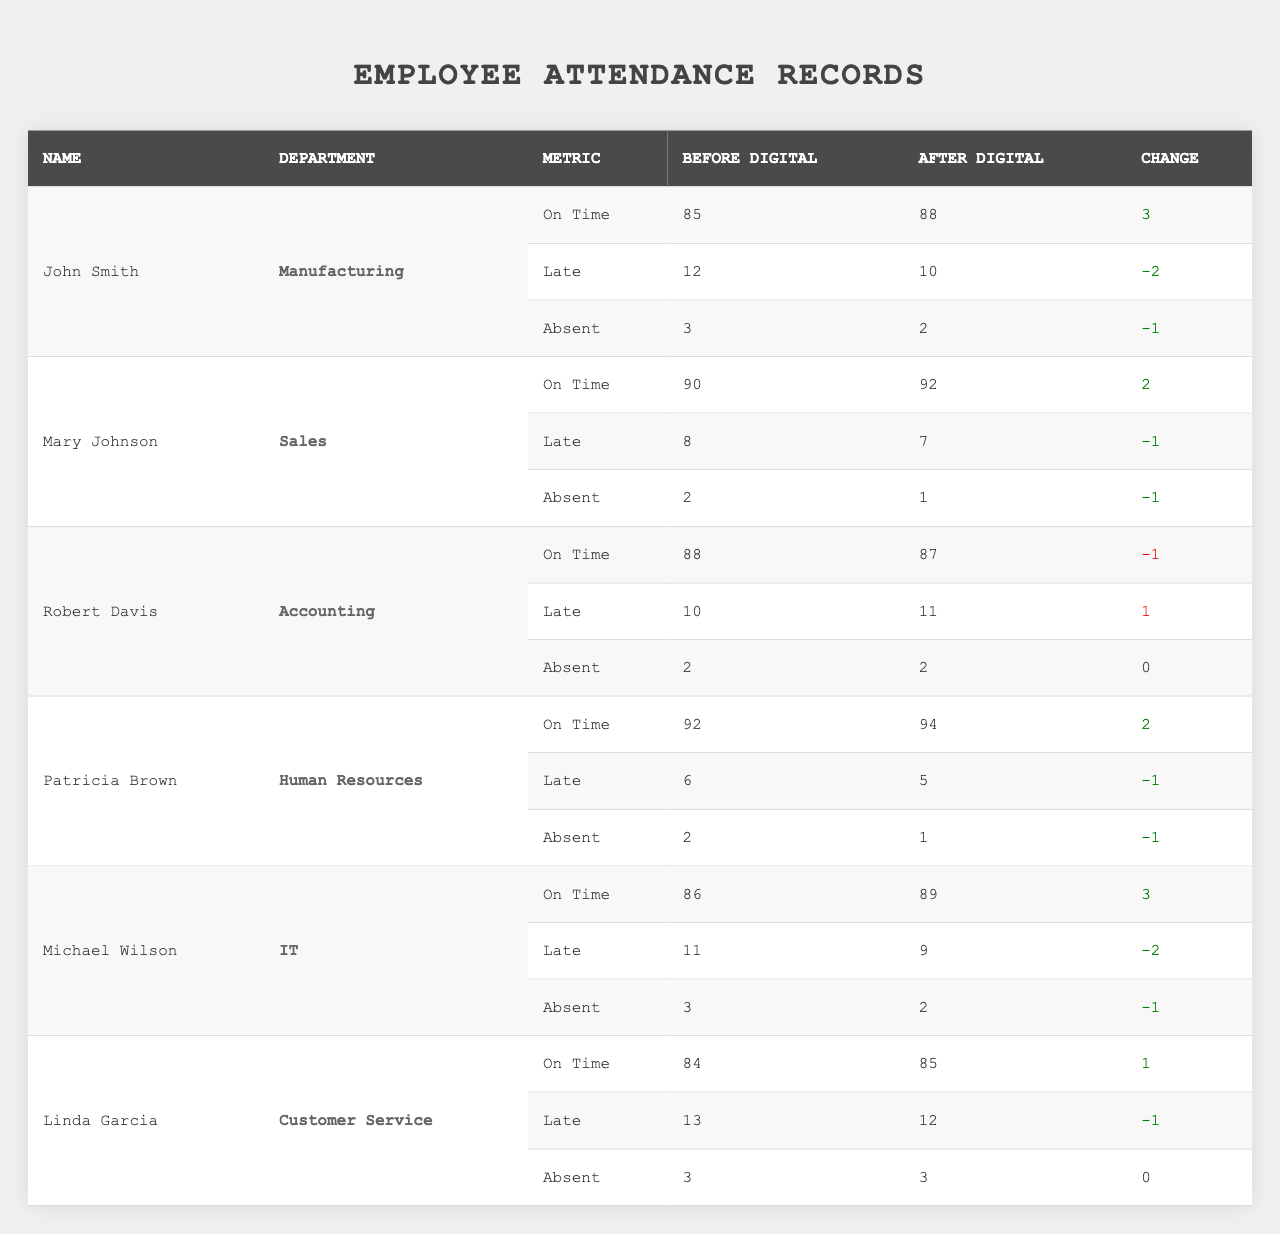What was the attendance record for John Smith before the digital check-in system? The table indicates that John Smith was on time 85 times, was late 12 times, and was absent 3 times. Therefore, the records are: On Time: 85, Late: 12, Absent: 3
Answer: 85 on time, 12 late, 3 absent Did Mary Johnson improve her on-time attendance after the digital system was implemented? By comparing the before and after values, Mary was on time 90 times before and 92 times after implementing the system. Since 92 is greater than 90, her on-time attendance improved.
Answer: Yes How many total times did Robert Davis arrive late before the digital system was in place? The table shows that Robert Davis was late 10 times before the digital system was implemented. Therefore, his late entries total to 10.
Answer: 10 What is the percentage improvement in on-time attendance for Patricia Brown? Patricia was on time 92 times before and 94 times after the system. The increase is 2 (94 - 92). To find the percentage improvement, we divide the increase by the original amount (2/92) and multiply by 100, giving approximately 2.17%.
Answer: Approximately 2.17% What was the total attendance breakdown for Michael Wilson before the digital check-in system? The table shows Michael had 86 on-time, 11 late, and 3 absent. Adding these up gives a total breakdown of 100 attendance records (86 + 11 + 3).
Answer: 86 on time, 11 late, 3 absent Is it true that all employees who switched to the digital system showed improvement in their on-time attendance? Reviewing the table, John Smith, Mary Johnson, Patricia Brown, and Michael Wilson all showed improvement in their on-time attendance, but Robert Davis showed a decrease (from 88 to 87). Thus, it is false that all employees improved.
Answer: No Who had the highest recorded absences before implementing the digital system? By examining the absence records, Linda Garcia and Michael Wilson both recorded 3 absences before the implementation, which is the highest compared to others.
Answer: Linda Garcia and Michael Wilson Which department saw the largest improvement in late arrivals after implementing the digital system? Comparing the late entries for each employee before and after implementation shows that Michael Wilson had an improvement of 2 (from 11 to 9), which is the largest improvement among all departments.
Answer: IT department What was the total number of absences across all employees after the digital check-in system was implemented? The total absences after implementation add up as follows: John Smith (2) + Mary Johnson (1) + Robert Davis (2) + Patricia Brown (1) + Michael Wilson (2) + Linda Garcia (3) = 11 absences total.
Answer: 11 absences Which employee experienced a deterioration in attendance after the digital check-in system? Assessing the records, Robert Davis's on-time attendance decreased from 88 to 87, indicating a deterioration.
Answer: Robert Davis What is the average attendance for all employees on time before the digital system? To find the average on-time attendance before digital implementation, we total the on-time records (85 + 90 + 88 + 92 + 86 + 84 = 525) and divide by the number of employees (6), giving an average of 87.5.
Answer: 87.5 